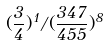<formula> <loc_0><loc_0><loc_500><loc_500>( \frac { 3 } { 4 } ) ^ { 1 } / ( \frac { 3 4 7 } { 4 5 5 } ) ^ { 8 }</formula> 